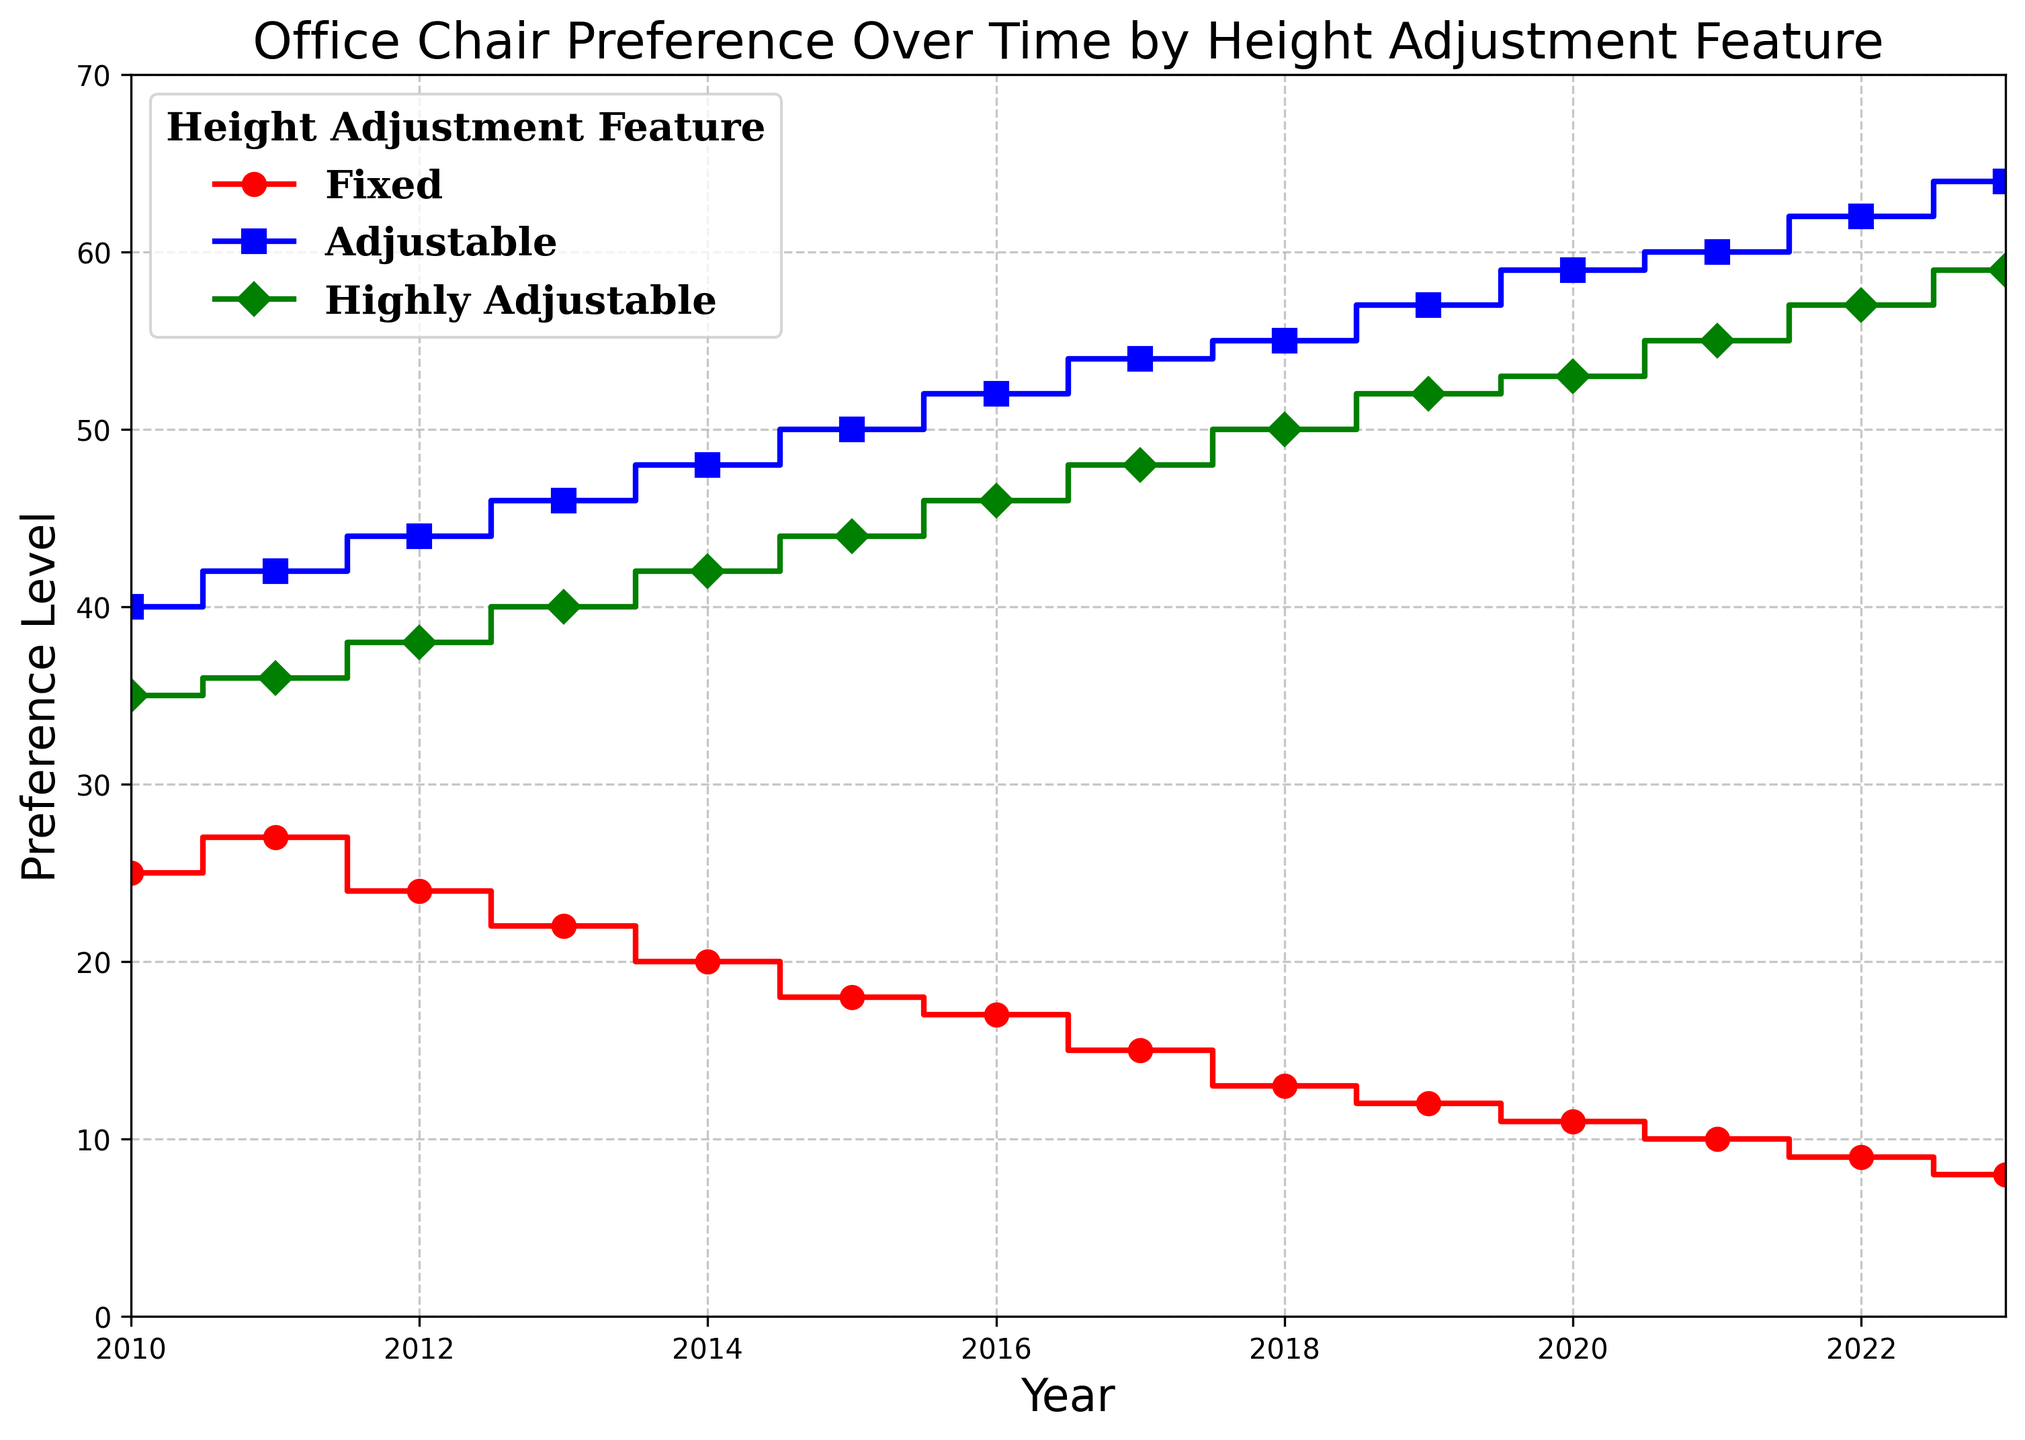Which height adjustment feature had the highest preference level in 2010? To determine which height adjustment feature had the highest preference level in 2010, we look at the preference levels for each feature in that year. The values are: Fixed (25), Adjustable (40), and Highly Adjustable (35). The highest value is 40 for the Adjustable feature.
Answer: Adjustable How did the preference level for the 'Fixed' feature change from 2013 to 2023? To find out how the preference level for the 'Fixed' feature changed from 2013 to 2023, we examine the values for these years. In 2013 the preference level was 22, and in 2023 it was 8. The change is 22 - 8 = 14, meaning a decrease of 14 units over these years.
Answer: Decreased by 14 Between 'Adjustable' and 'Highly Adjustable' features, which had a higher preference level on average over the entire period? To compare the average preference levels, sum the preference levels for each feature over the years and then divide by the number of years (14). For Adjustable: (40+42+44+46+48+50+52+54+55+57+59+60+62+64)/14 = 52.5. For Highly Adjustable: (35+36+38+40+42+44+46+48+50+52+53+55+57+59)/14 ≈ 46.14. The 'Adjustable' feature had a higher average preference level.
Answer: Adjustable What is the trend for the 'Highly Adjustable' feature from 2010 to 2023? To identify the trend for the 'Highly Adjustable' feature, we observe the preference levels over the years. From 2010 (35) to 2023 (59), the preference levels are steadily increasing each year. This indicates a consistently upward trend.
Answer: Increasing In which year did all three features have the closest preference levels? To find the year with the closest preference levels among all three features, we need to look at the preference levels for each year and compare the differences. In 2010, the levels were: Fixed (25), Adjustable (40), and Highly Adjustable (35), with differences of 15 and 5. Other years show larger differences. Therefore, 2010 had the closest levels.
Answer: 2010 